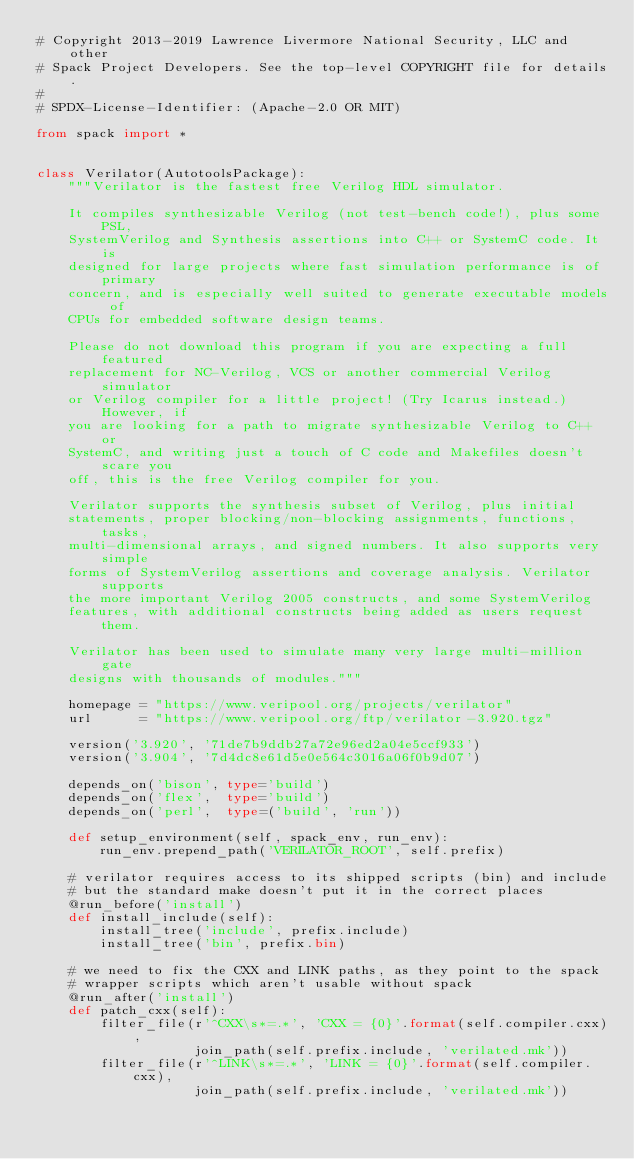Convert code to text. <code><loc_0><loc_0><loc_500><loc_500><_Python_># Copyright 2013-2019 Lawrence Livermore National Security, LLC and other
# Spack Project Developers. See the top-level COPYRIGHT file for details.
#
# SPDX-License-Identifier: (Apache-2.0 OR MIT)

from spack import *


class Verilator(AutotoolsPackage):
    """Verilator is the fastest free Verilog HDL simulator.

    It compiles synthesizable Verilog (not test-bench code!), plus some PSL,
    SystemVerilog and Synthesis assertions into C++ or SystemC code. It is
    designed for large projects where fast simulation performance is of primary
    concern, and is especially well suited to generate executable models of
    CPUs for embedded software design teams.

    Please do not download this program if you are expecting a full featured
    replacement for NC-Verilog, VCS or another commercial Verilog simulator
    or Verilog compiler for a little project! (Try Icarus instead.) However, if
    you are looking for a path to migrate synthesizable Verilog to C++ or
    SystemC, and writing just a touch of C code and Makefiles doesn't scare you
    off, this is the free Verilog compiler for you.

    Verilator supports the synthesis subset of Verilog, plus initial
    statements, proper blocking/non-blocking assignments, functions, tasks,
    multi-dimensional arrays, and signed numbers. It also supports very simple
    forms of SystemVerilog assertions and coverage analysis. Verilator supports
    the more important Verilog 2005 constructs, and some SystemVerilog
    features, with additional constructs being added as users request them.

    Verilator has been used to simulate many very large multi-million gate
    designs with thousands of modules."""

    homepage = "https://www.veripool.org/projects/verilator"
    url      = "https://www.veripool.org/ftp/verilator-3.920.tgz"

    version('3.920', '71de7b9ddb27a72e96ed2a04e5ccf933')
    version('3.904', '7d4dc8e61d5e0e564c3016a06f0b9d07')

    depends_on('bison', type='build')
    depends_on('flex',  type='build')
    depends_on('perl',  type=('build', 'run'))

    def setup_environment(self, spack_env, run_env):
        run_env.prepend_path('VERILATOR_ROOT', self.prefix)

    # verilator requires access to its shipped scripts (bin) and include
    # but the standard make doesn't put it in the correct places
    @run_before('install')
    def install_include(self):
        install_tree('include', prefix.include)
        install_tree('bin', prefix.bin)

    # we need to fix the CXX and LINK paths, as they point to the spack
    # wrapper scripts which aren't usable without spack
    @run_after('install')
    def patch_cxx(self):
        filter_file(r'^CXX\s*=.*', 'CXX = {0}'.format(self.compiler.cxx),
                    join_path(self.prefix.include, 'verilated.mk'))
        filter_file(r'^LINK\s*=.*', 'LINK = {0}'.format(self.compiler.cxx),
                    join_path(self.prefix.include, 'verilated.mk'))
</code> 